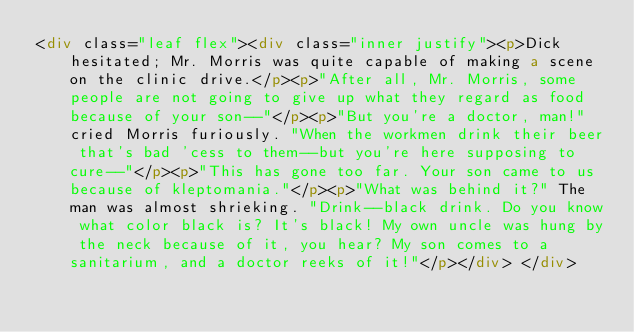<code> <loc_0><loc_0><loc_500><loc_500><_HTML_><div class="leaf flex"><div class="inner justify"><p>Dick hesitated; Mr. Morris was quite capable of making a scene on the clinic drive.</p><p>"After all, Mr. Morris, some people are not going to give up what they regard as food because of your son--"</p><p>"But you're a doctor, man!" cried Morris furiously. "When the workmen drink their beer that's bad 'cess to them--but you're here supposing to cure--"</p><p>"This has gone too far. Your son came to us because of kleptomania."</p><p>"What was behind it?" The man was almost shrieking. "Drink--black drink. Do you know what color black is? It's black! My own uncle was hung by the neck because of it, you hear? My son comes to a sanitarium, and a doctor reeks of it!"</p></div> </div></code> 